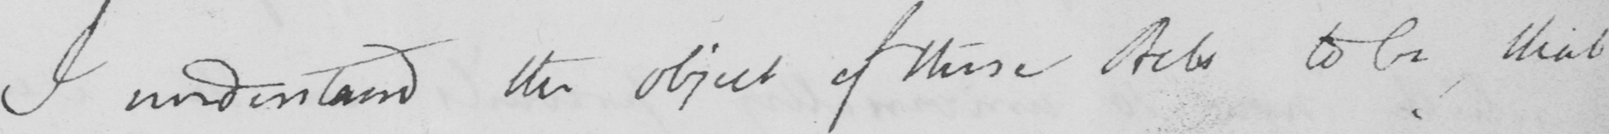Can you tell me what this handwritten text says? I understand the object of these Acts to be, that 